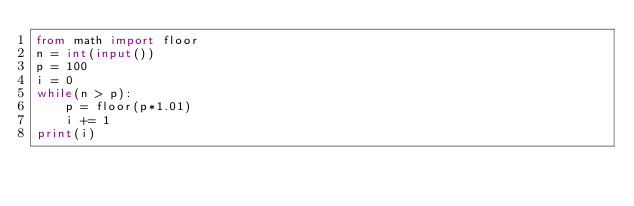Convert code to text. <code><loc_0><loc_0><loc_500><loc_500><_Python_>from math import floor
n = int(input())
p = 100
i = 0
while(n > p):
    p = floor(p*1.01)
    i += 1
print(i)</code> 